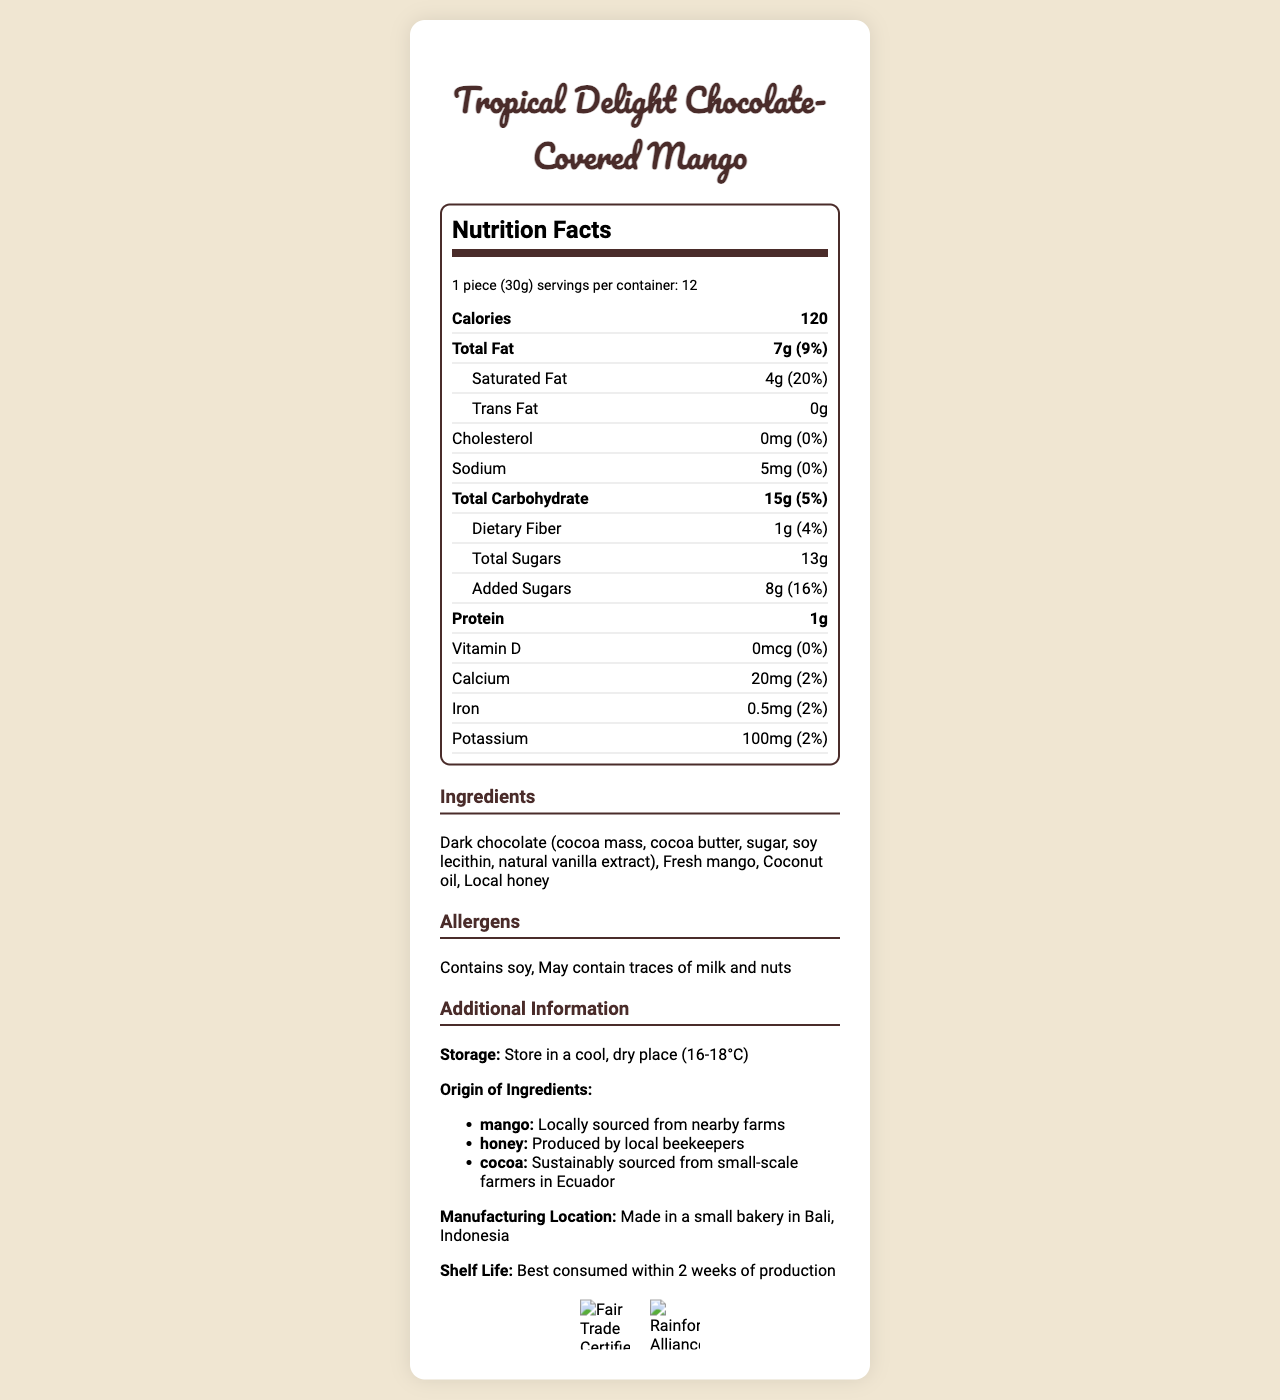what is the serving size? The serving size is explicitly listed at the beginning of the Nutrition Facts section as "1 piece (30g)".
Answer: 1 piece (30g) how many servings are there per container? The document states that there are 12 servings per container in the serving info section.
Answer: 12 how many calories are in one serving? The number of calories per serving is highlighted under the "Calories" section in the Nutrition Facts.
Answer: 120 which ingredients are locally sourced? The origin of ingredients section states that the mango is "Locally sourced from nearby farms" and the honey is "Produced by local beekeepers".
Answer: Mango, honey what is the amount of sodium in one serving? The sodium content is listed as 5mg under the sodium row in the Nutrition Facts.
Answer: 5mg what is the daily value percentage for saturated fat? The daily value for saturated fat is provided as 20%.
Answer: 20% does the product contain any allergens? The allergens section mentions that the product "Contains soy" and "May contain traces of milk and nuts".
Answer: Yes how much total fat is in one serving? A. 5g B. 7g C. 10g D. 1g The total fat content is stated as 7g in the Nutrition Facts.
Answer: B. 7g what is the cholesterol content in one serving? A. 5mg B. 0mg C. 10mg D. 50mg The cholesterol content is listed as 0mg in the Nutrition Facts.
Answer: B. 0mg what is the total carbohydrate content in one serving? The total carbohydrate content is listed as 15g in the Nutrition Facts.
Answer: 15g what certification does this product have? There are images and text mentioning the Fair Trade Certified and Rainforest Alliance Certified certifications.
Answer: Fair Trade Certified, Rainforest Alliance Certified does this product have added sugars? The Nutrition Facts states that the product contains 8g of added sugars.
Answer: Yes describe the main idea of this document. The document lists detailed nutritional facts, ingredients, allergens, and additional information about the Tropical Delight Chocolate-Covered Mango, highlighting its locally sourced and sustainably certified components.
Answer: The document provides comprehensive nutritional information for "Tropical Delight Chocolate-Covered Mango", including serving size, calorie count, macronutrient and micronutrient distribution, ingredients, allergen information, storage instructions, origin of ingredients, and certifications. how much protein is in one serving of this product? The protein content per serving is listed as 1g in the Nutrition Facts.
Answer: 1g how much Vitamin D does this product provide? The Vitamin D content is listed as 0mcg with a daily value of 0%.
Answer: 0mcg (0%) what is the manufacturing location of this product? The additional information section specifies that the product is made in Bali, Indonesia.
Answer: Made in a small bakery in Bali, Indonesia what ingredient is used to sweeten the product? The ingredients list mentions 'Local honey' as one of the ingredients.
Answer: Local honey is there any iron in one serving of this product? The iron content is listed as 0.5mg in the Nutrition Facts.
Answer: Yes, 0.5mg how long is the shelf life of this product? The additional information section states the shelf life as "Best consumed within 2 weeks of production".
Answer: Best consumed within 2 weeks of production what is the main ingredient of this product? The document lists all ingredients but does not specify the main ingredient.
Answer: Cannot be determined 